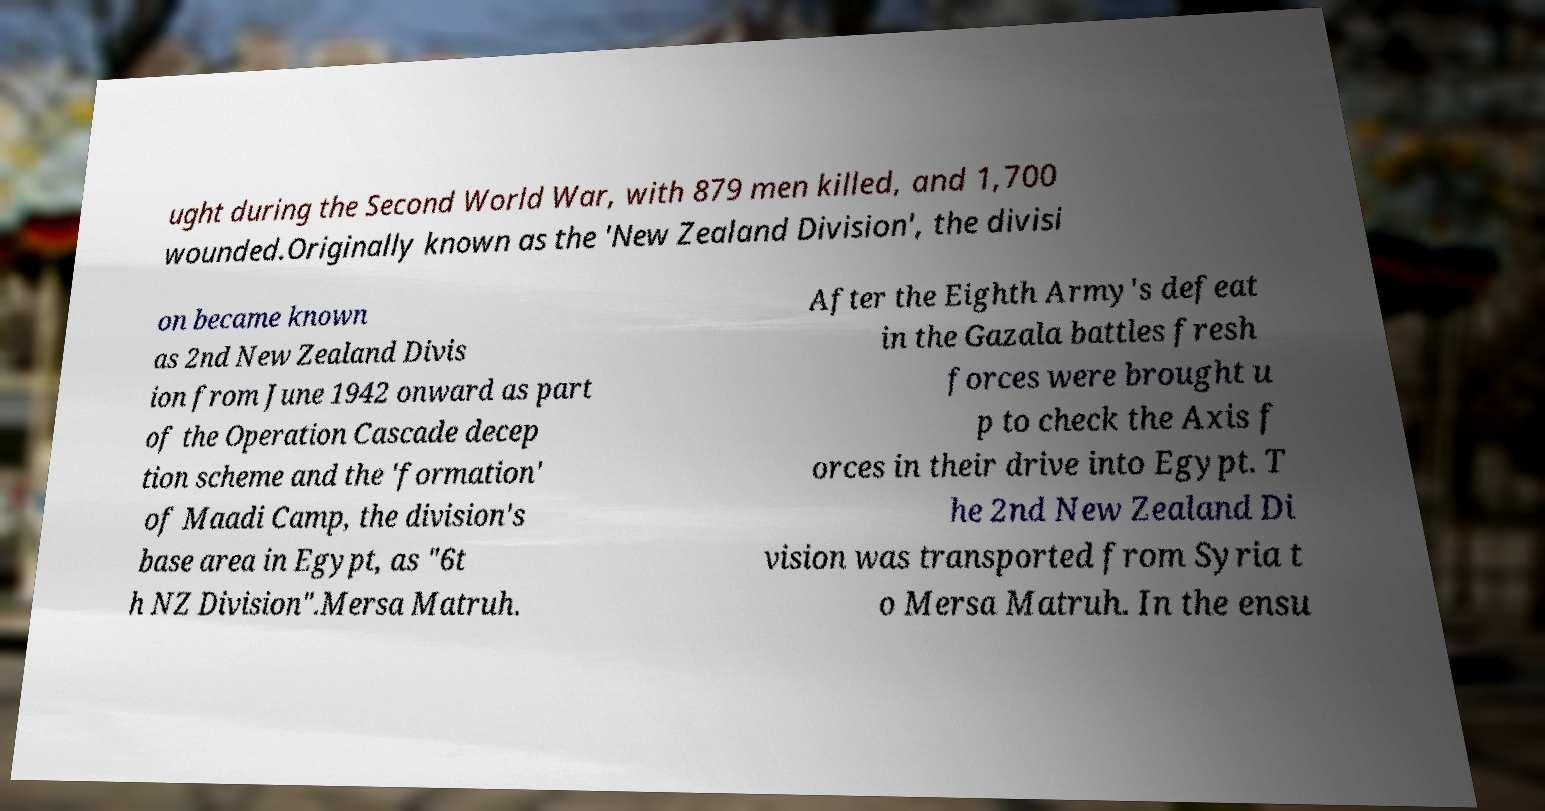What messages or text are displayed in this image? I need them in a readable, typed format. ught during the Second World War, with 879 men killed, and 1,700 wounded.Originally known as the 'New Zealand Division', the divisi on became known as 2nd New Zealand Divis ion from June 1942 onward as part of the Operation Cascade decep tion scheme and the 'formation' of Maadi Camp, the division's base area in Egypt, as "6t h NZ Division".Mersa Matruh. After the Eighth Army's defeat in the Gazala battles fresh forces were brought u p to check the Axis f orces in their drive into Egypt. T he 2nd New Zealand Di vision was transported from Syria t o Mersa Matruh. In the ensu 